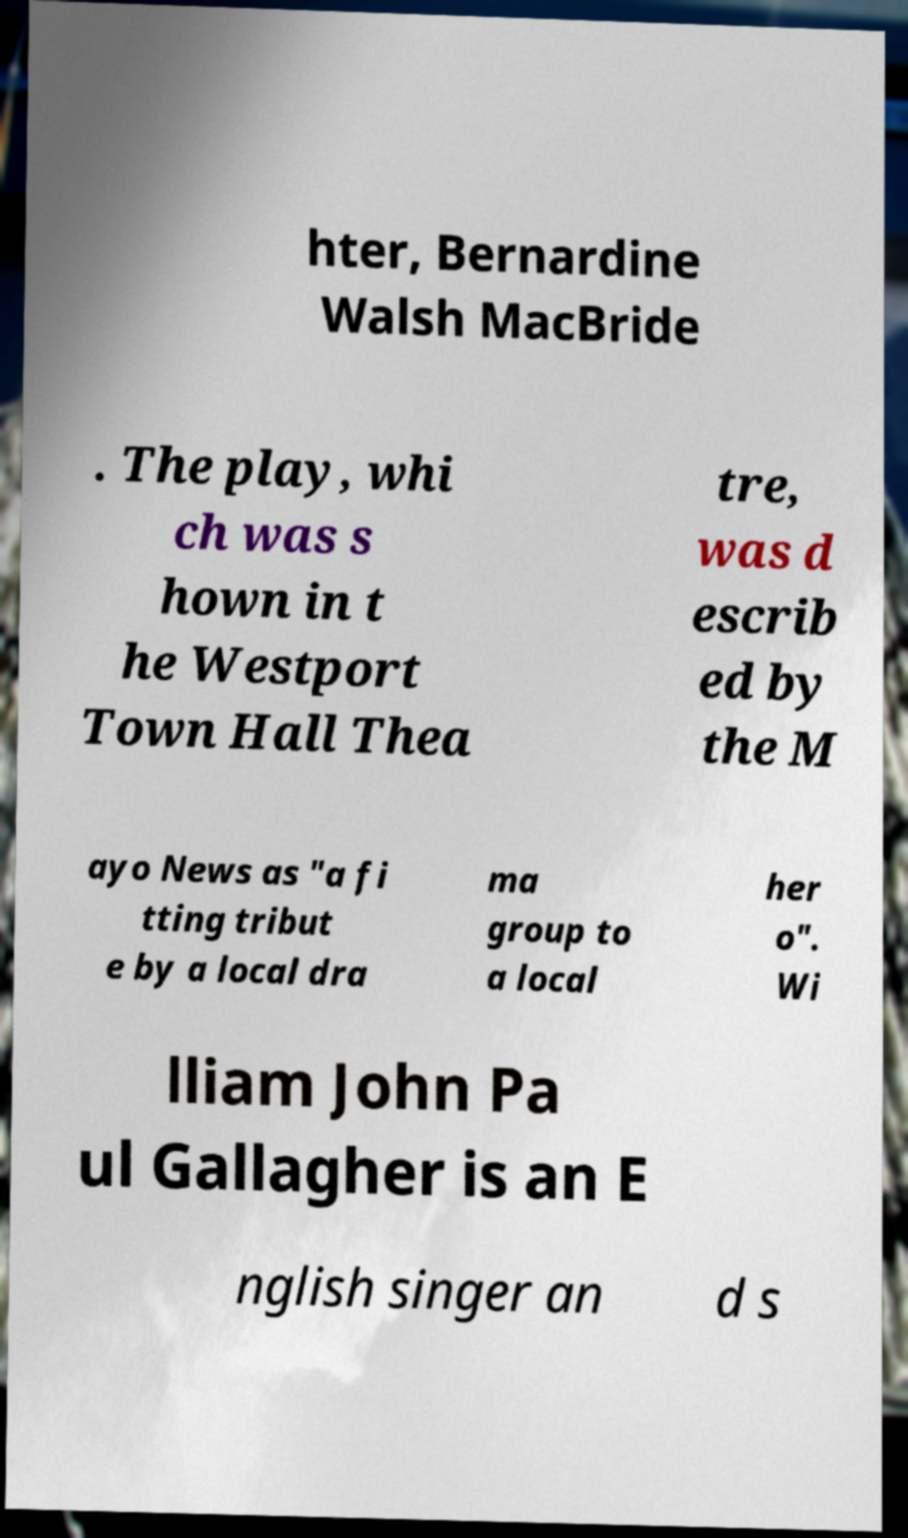I need the written content from this picture converted into text. Can you do that? hter, Bernardine Walsh MacBride . The play, whi ch was s hown in t he Westport Town Hall Thea tre, was d escrib ed by the M ayo News as "a fi tting tribut e by a local dra ma group to a local her o". Wi lliam John Pa ul Gallagher is an E nglish singer an d s 